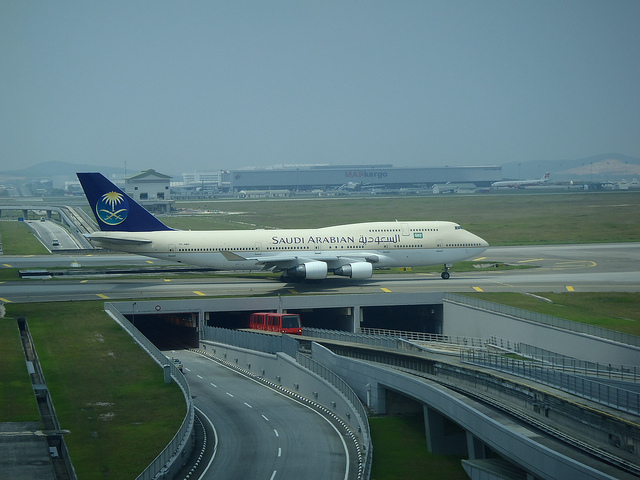Extract all visible text content from this image. SAUDI ARABIAN 